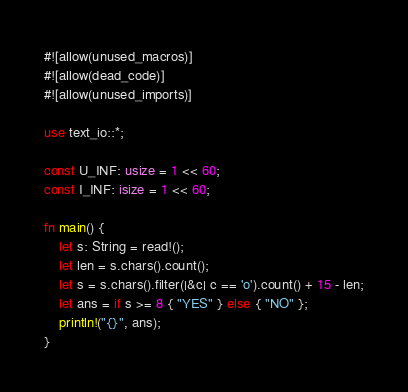<code> <loc_0><loc_0><loc_500><loc_500><_Rust_>#![allow(unused_macros)]
#![allow(dead_code)]
#![allow(unused_imports)]

use text_io::*;

const U_INF: usize = 1 << 60;
const I_INF: isize = 1 << 60;

fn main() {
    let s: String = read!();
    let len = s.chars().count();
    let s = s.chars().filter(|&c| c == 'o').count() + 15 - len;
    let ans = if s >= 8 { "YES" } else { "NO" };
    println!("{}", ans);
}
</code> 